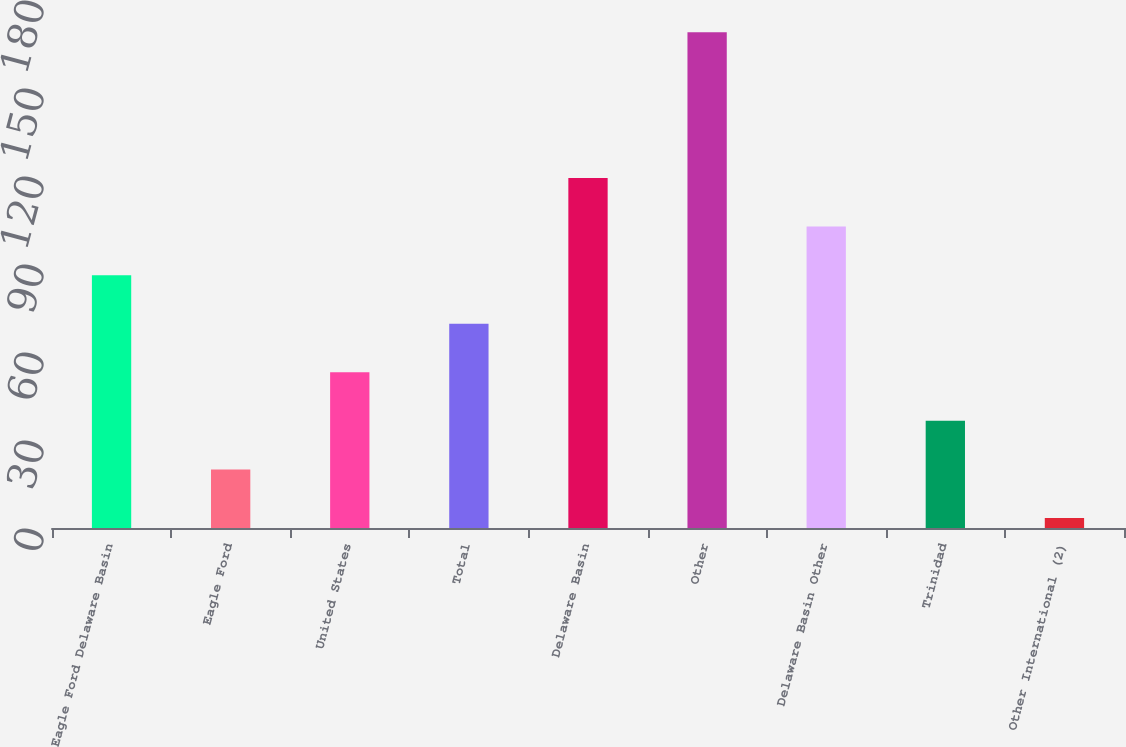Convert chart to OTSL. <chart><loc_0><loc_0><loc_500><loc_500><bar_chart><fcel>Eagle Ford Delaware Basin<fcel>Eagle Ford<fcel>United States<fcel>Total<fcel>Delaware Basin<fcel>Other<fcel>Delaware Basin Other<fcel>Trinidad<fcel>Other International (2)<nl><fcel>86.2<fcel>19.96<fcel>53.08<fcel>69.64<fcel>119.32<fcel>169<fcel>102.76<fcel>36.52<fcel>3.4<nl></chart> 